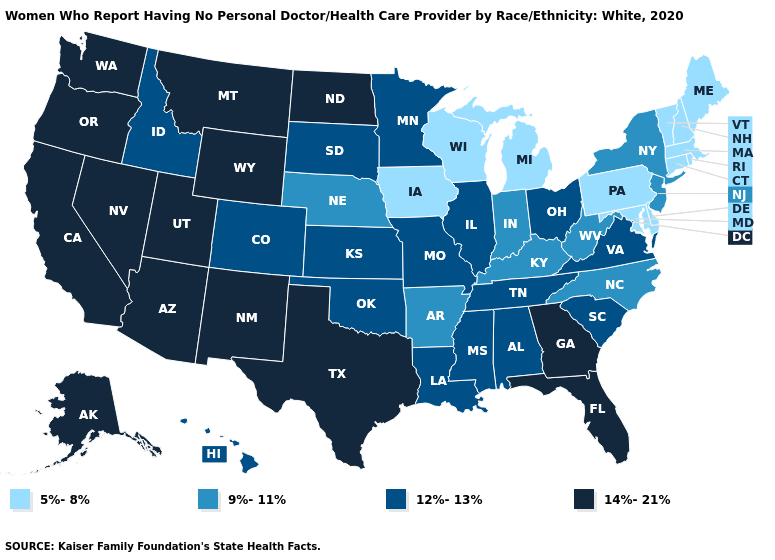Name the states that have a value in the range 5%-8%?
Quick response, please. Connecticut, Delaware, Iowa, Maine, Maryland, Massachusetts, Michigan, New Hampshire, Pennsylvania, Rhode Island, Vermont, Wisconsin. What is the lowest value in the MidWest?
Be succinct. 5%-8%. Does Oklahoma have the same value as Vermont?
Write a very short answer. No. Name the states that have a value in the range 14%-21%?
Be succinct. Alaska, Arizona, California, Florida, Georgia, Montana, Nevada, New Mexico, North Dakota, Oregon, Texas, Utah, Washington, Wyoming. Does Pennsylvania have the highest value in the USA?
Be succinct. No. Which states have the highest value in the USA?
Answer briefly. Alaska, Arizona, California, Florida, Georgia, Montana, Nevada, New Mexico, North Dakota, Oregon, Texas, Utah, Washington, Wyoming. Name the states that have a value in the range 12%-13%?
Short answer required. Alabama, Colorado, Hawaii, Idaho, Illinois, Kansas, Louisiana, Minnesota, Mississippi, Missouri, Ohio, Oklahoma, South Carolina, South Dakota, Tennessee, Virginia. What is the lowest value in the USA?
Keep it brief. 5%-8%. What is the value of New Jersey?
Write a very short answer. 9%-11%. Name the states that have a value in the range 14%-21%?
Answer briefly. Alaska, Arizona, California, Florida, Georgia, Montana, Nevada, New Mexico, North Dakota, Oregon, Texas, Utah, Washington, Wyoming. What is the value of Iowa?
Give a very brief answer. 5%-8%. Which states have the lowest value in the Northeast?
Write a very short answer. Connecticut, Maine, Massachusetts, New Hampshire, Pennsylvania, Rhode Island, Vermont. Does Arizona have the highest value in the West?
Write a very short answer. Yes. What is the value of California?
Be succinct. 14%-21%. What is the highest value in states that border Maine?
Be succinct. 5%-8%. 